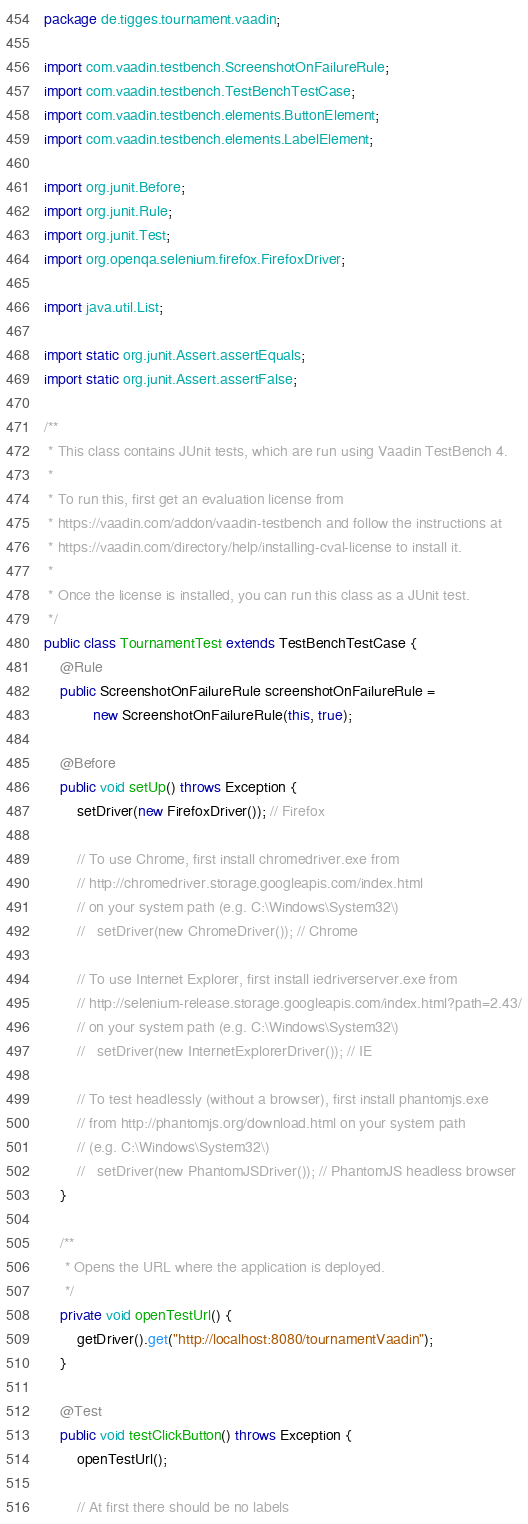Convert code to text. <code><loc_0><loc_0><loc_500><loc_500><_Java_>package de.tigges.tournament.vaadin;

import com.vaadin.testbench.ScreenshotOnFailureRule;
import com.vaadin.testbench.TestBenchTestCase;
import com.vaadin.testbench.elements.ButtonElement;
import com.vaadin.testbench.elements.LabelElement;

import org.junit.Before;
import org.junit.Rule;
import org.junit.Test;
import org.openqa.selenium.firefox.FirefoxDriver;

import java.util.List;

import static org.junit.Assert.assertEquals;
import static org.junit.Assert.assertFalse;

/**
 * This class contains JUnit tests, which are run using Vaadin TestBench 4.
 *
 * To run this, first get an evaluation license from
 * https://vaadin.com/addon/vaadin-testbench and follow the instructions at
 * https://vaadin.com/directory/help/installing-cval-license to install it.
 *
 * Once the license is installed, you can run this class as a JUnit test.
 */
public class TournamentTest extends TestBenchTestCase {
    @Rule
    public ScreenshotOnFailureRule screenshotOnFailureRule =
            new ScreenshotOnFailureRule(this, true);

    @Before
    public void setUp() throws Exception {
        setDriver(new FirefoxDriver()); // Firefox

        // To use Chrome, first install chromedriver.exe from
        // http://chromedriver.storage.googleapis.com/index.html
        // on your system path (e.g. C:\Windows\System32\)
        //   setDriver(new ChromeDriver()); // Chrome

        // To use Internet Explorer, first install iedriverserver.exe from
        // http://selenium-release.storage.googleapis.com/index.html?path=2.43/
        // on your system path (e.g. C:\Windows\System32\)
        //   setDriver(new InternetExplorerDriver()); // IE

        // To test headlessly (without a browser), first install phantomjs.exe
        // from http://phantomjs.org/download.html on your system path
        // (e.g. C:\Windows\System32\)
        //   setDriver(new PhantomJSDriver()); // PhantomJS headless browser
    }

    /**
     * Opens the URL where the application is deployed.
     */
    private void openTestUrl() {
        getDriver().get("http://localhost:8080/tournamentVaadin");
    }

    @Test
    public void testClickButton() throws Exception {
        openTestUrl();

        // At first there should be no labels</code> 